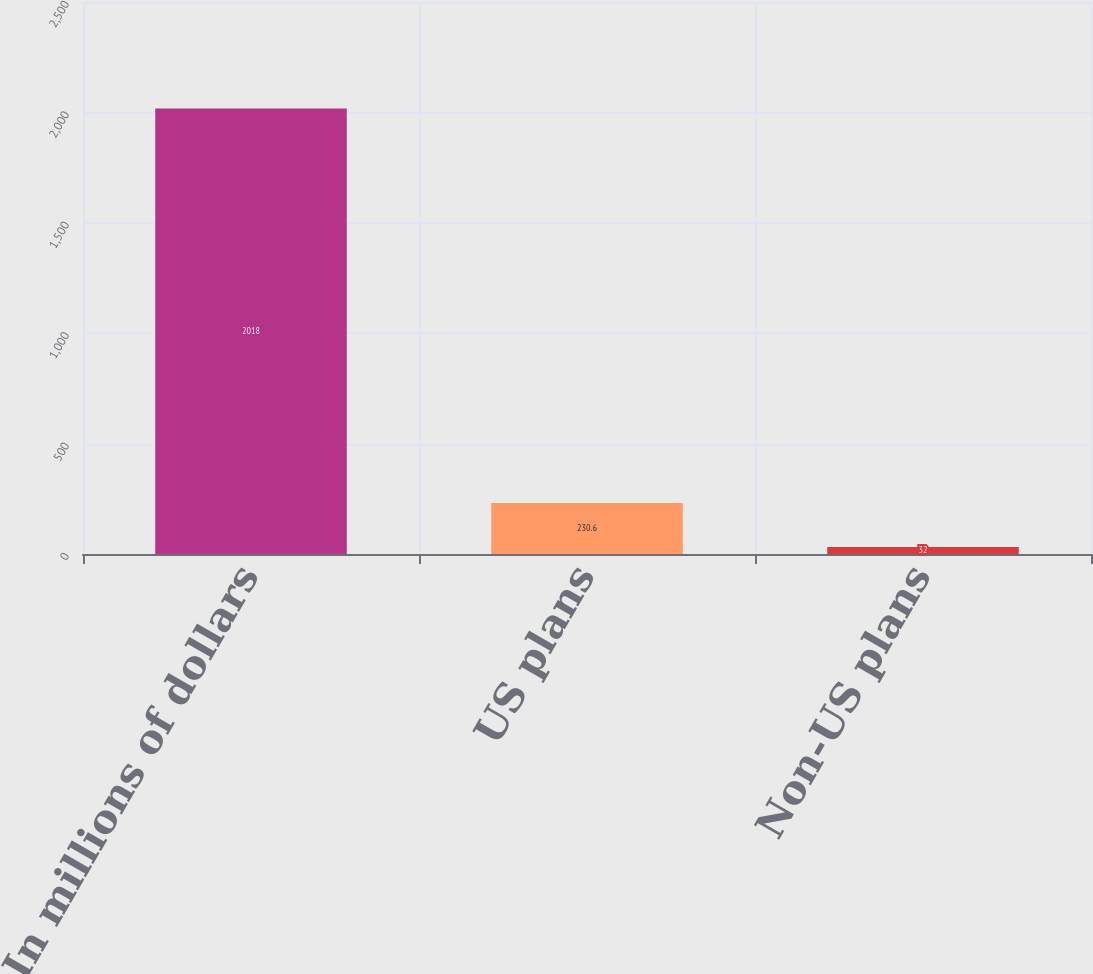Convert chart to OTSL. <chart><loc_0><loc_0><loc_500><loc_500><bar_chart><fcel>In millions of dollars<fcel>US plans<fcel>Non-US plans<nl><fcel>2018<fcel>230.6<fcel>32<nl></chart> 